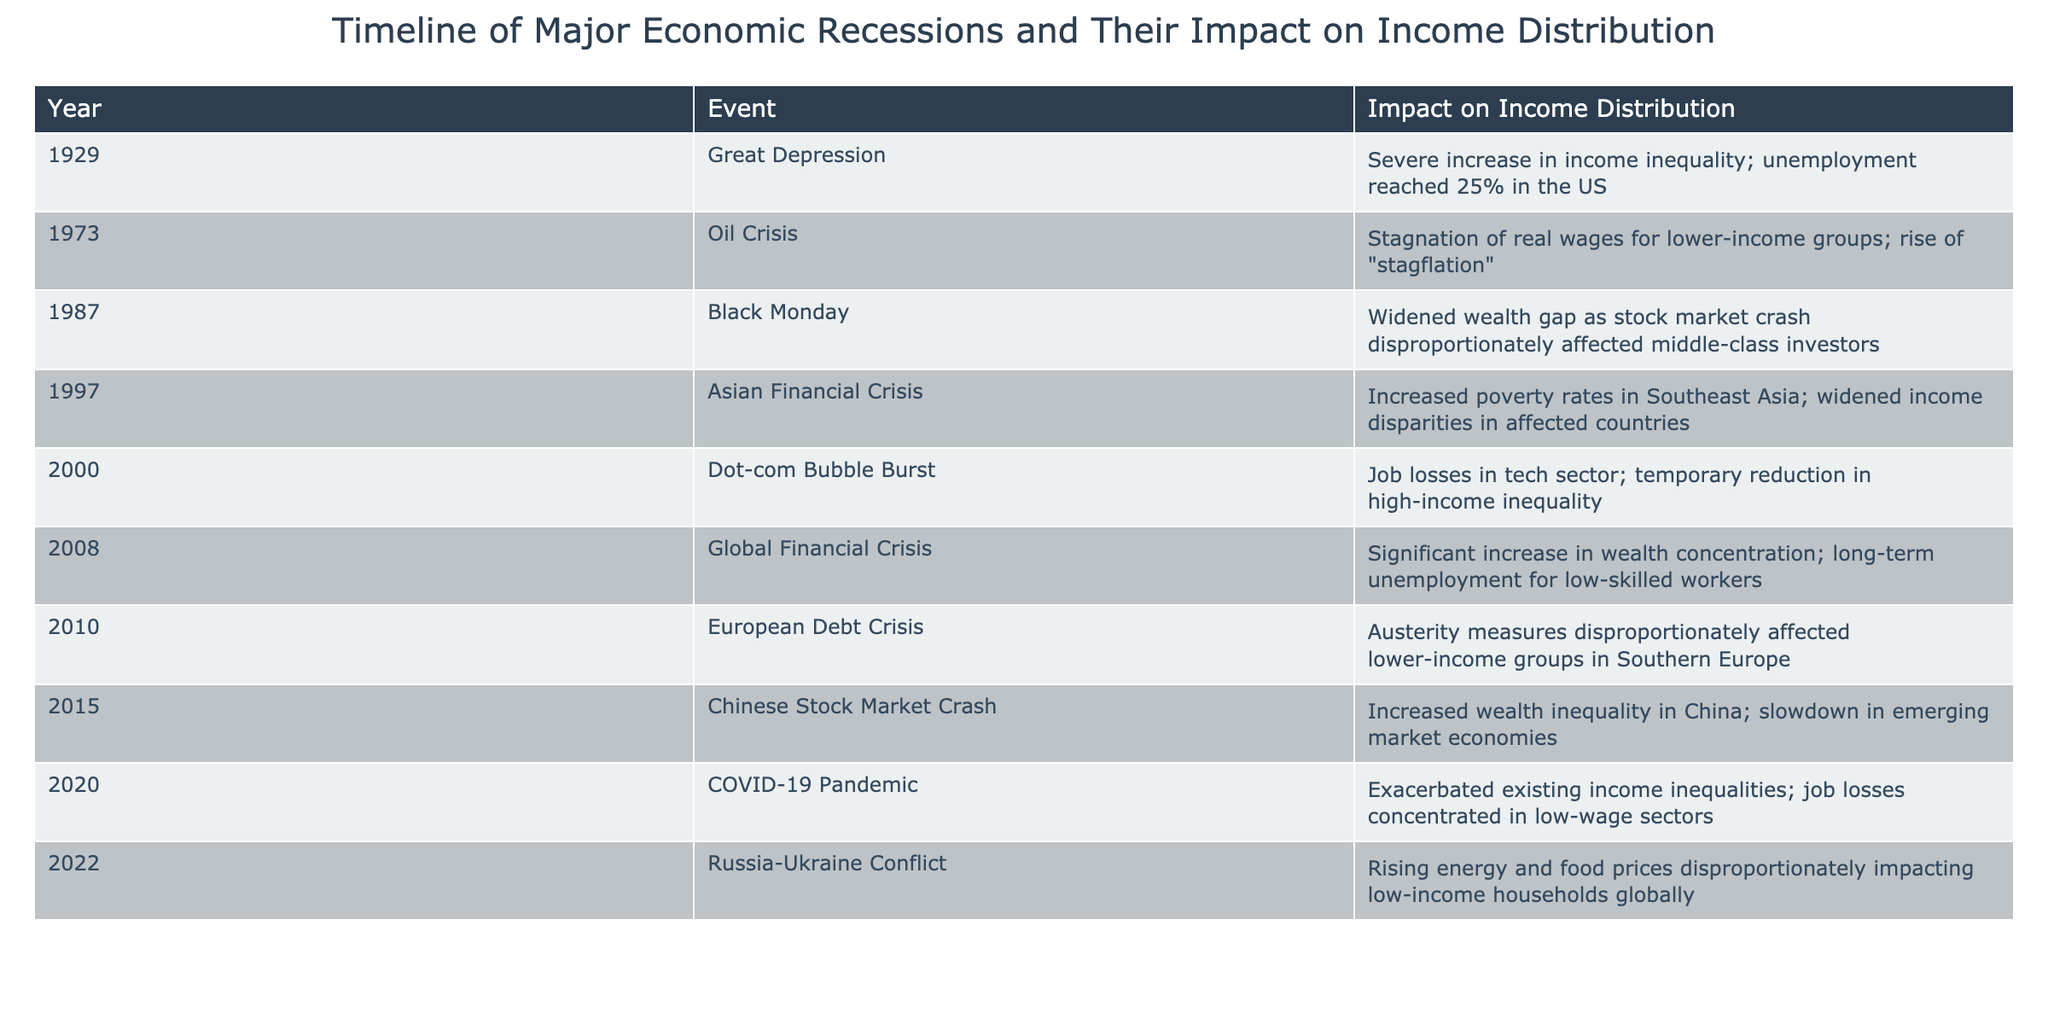What year did the Great Depression occur? The table lists the Great Depression under the Year column, which shows 1929 as the year of this event.
Answer: 1929 What is the impact of the COVID-19 Pandemic on income distribution? According to the table, the impact of the COVID-19 Pandemic is that it exacerbated existing income inequalities and resulted in job losses concentrated in low-wage sectors.
Answer: Exacerbated existing income inequalities and job losses in low-wage sectors Which events resulted in a significant increase in income inequality? The table shows several events with notable impacts on income inequality, specifically the Great Depression in 1929, the Global Financial Crisis in 2008, and the COVID-19 Pandemic in 2020.
Answer: Great Depression, Global Financial Crisis, COVID-19 Pandemic How many events listed had a directly negative impact on lower-income groups? From the table, the events affecting lower-income groups specifically are the European Debt Crisis in 2010 and the COVID-19 Pandemic in 2020. There are 2 such events.
Answer: 2 Is it true that the 1973 Oil Crisis led to higher real wages? The table indicates that the Oil Crisis led to stagnation of real wages for lower-income groups, which means this statement is false.
Answer: No What was the impact of the 1997 Asian Financial Crisis on poverty rates? The table notes that the Asian Financial Crisis led to increased poverty rates in Southeast Asia, which indicates a negative impact on income distribution.
Answer: Increased poverty rates in Southeast Asia Which year had the highest unemployment rate reported, and what was that rate? The table indicates that the Great Depression in 1929 brought unemployment to 25% in the US, making it the highest rate reported in the table.
Answer: 1929, 25% What is the total number of events listed that occurred in the 21st century? The table shows that six events occurred in the 21st century: the Dot-com Bubble Burst in 2000, the Global Financial Crisis in 2008, the European Debt Crisis in 2010, the Chinese Stock Market Crash in 2015, the COVID-19 Pandemic in 2020, and the Russia-Ukraine Conflict in 2022. Thus, the total count is 6.
Answer: 6 Explain the change in income inequality during the period from the Dot-com Bubble Burst to the Global Financial Crisis. The Dot-com Bubble Burst in 2000 resulted in a temporary reduction in high-income inequality, suggesting that wealth became more evenly distributed at that time. However, the Global Financial Crisis in 2008 led to a significant increase in wealth concentration, indicating that income inequality rose sharply following the Dot-com period.
Answer: Increased after the Dot-com period 